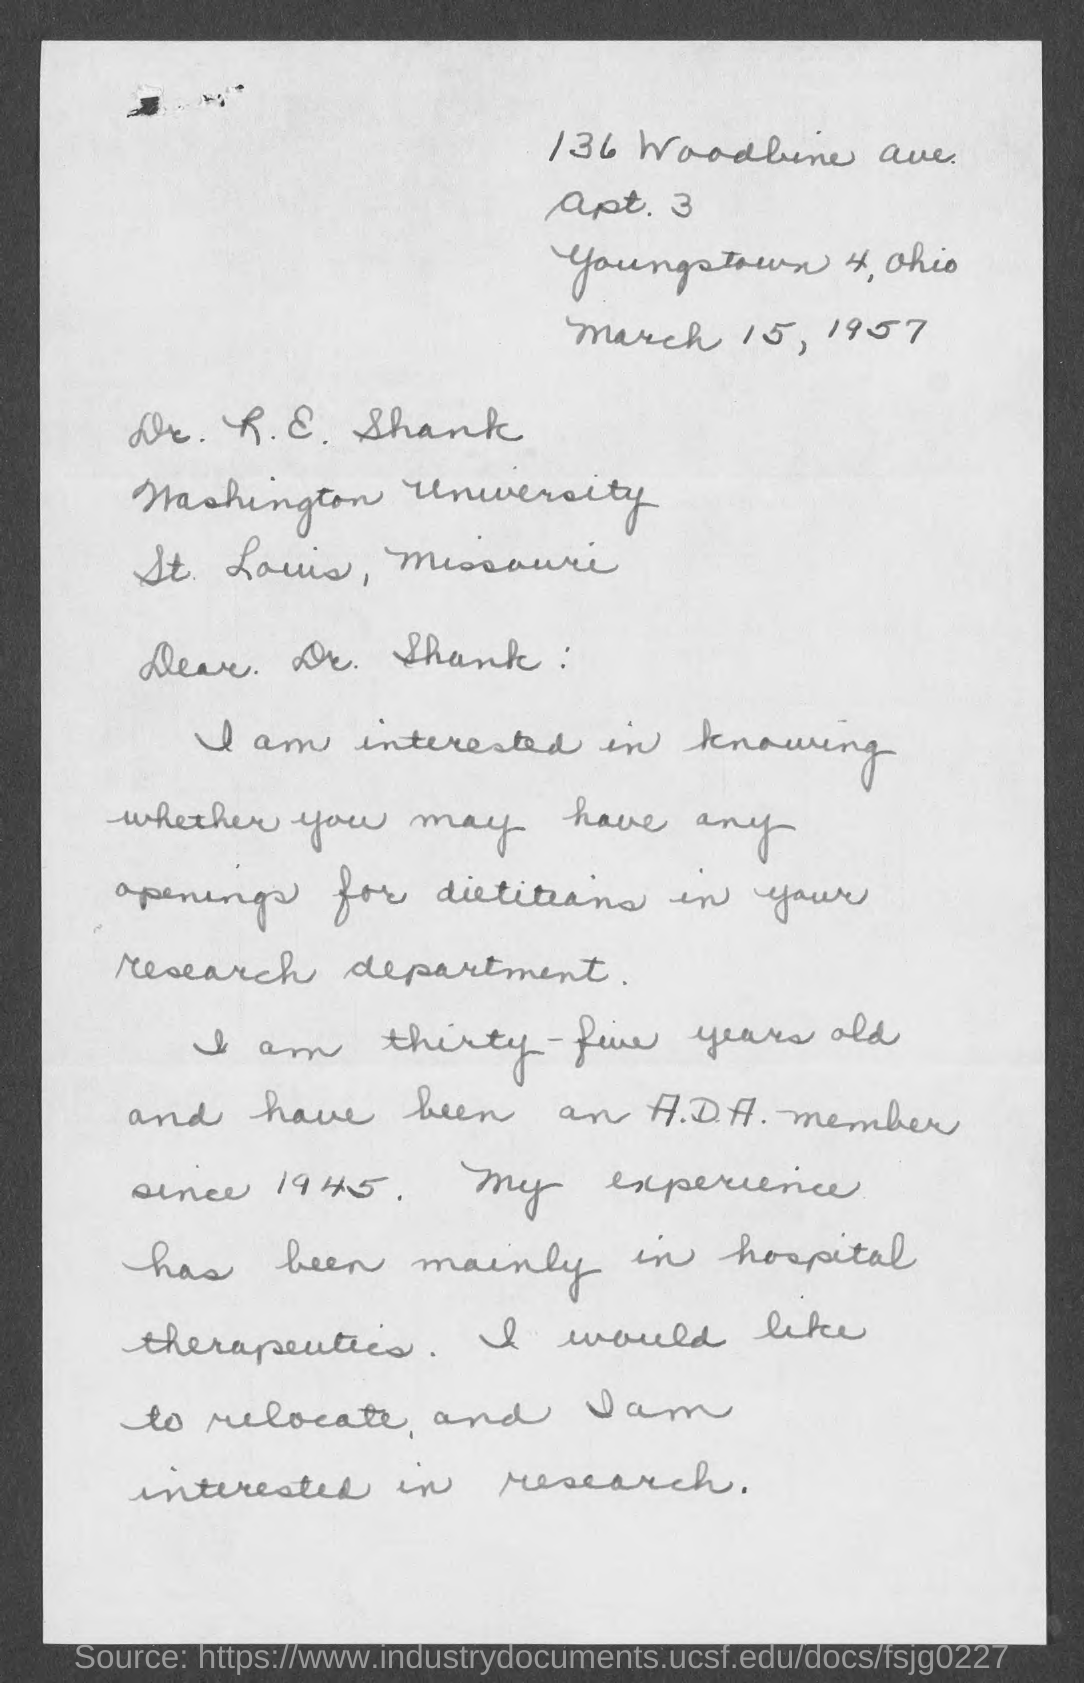What is the date mentioned in the given letter ?
Provide a short and direct response. March 15, 1957. 